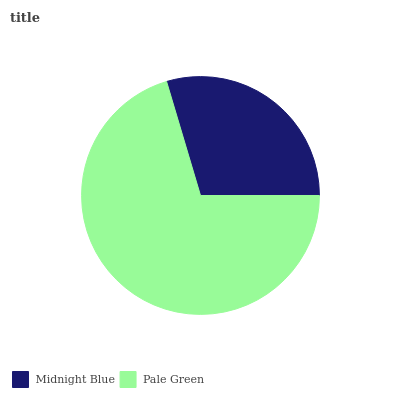Is Midnight Blue the minimum?
Answer yes or no. Yes. Is Pale Green the maximum?
Answer yes or no. Yes. Is Pale Green the minimum?
Answer yes or no. No. Is Pale Green greater than Midnight Blue?
Answer yes or no. Yes. Is Midnight Blue less than Pale Green?
Answer yes or no. Yes. Is Midnight Blue greater than Pale Green?
Answer yes or no. No. Is Pale Green less than Midnight Blue?
Answer yes or no. No. Is Pale Green the high median?
Answer yes or no. Yes. Is Midnight Blue the low median?
Answer yes or no. Yes. Is Midnight Blue the high median?
Answer yes or no. No. Is Pale Green the low median?
Answer yes or no. No. 